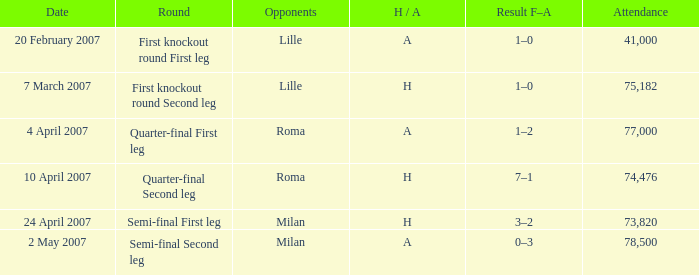Which round has an Opponent of lille, and a H / A of h? First knockout round Second leg. 